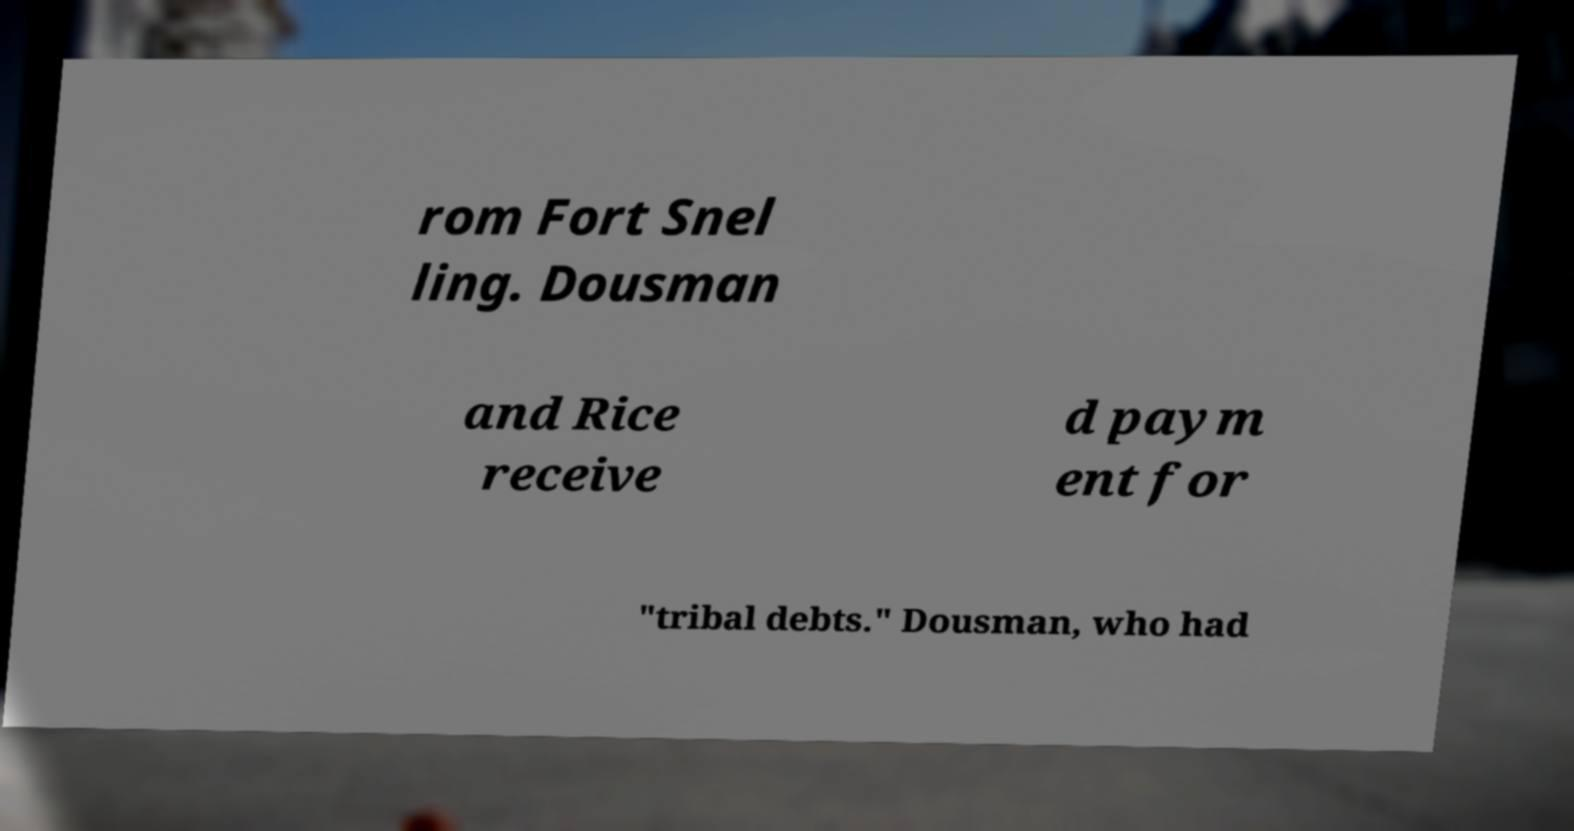Can you accurately transcribe the text from the provided image for me? rom Fort Snel ling. Dousman and Rice receive d paym ent for "tribal debts." Dousman, who had 